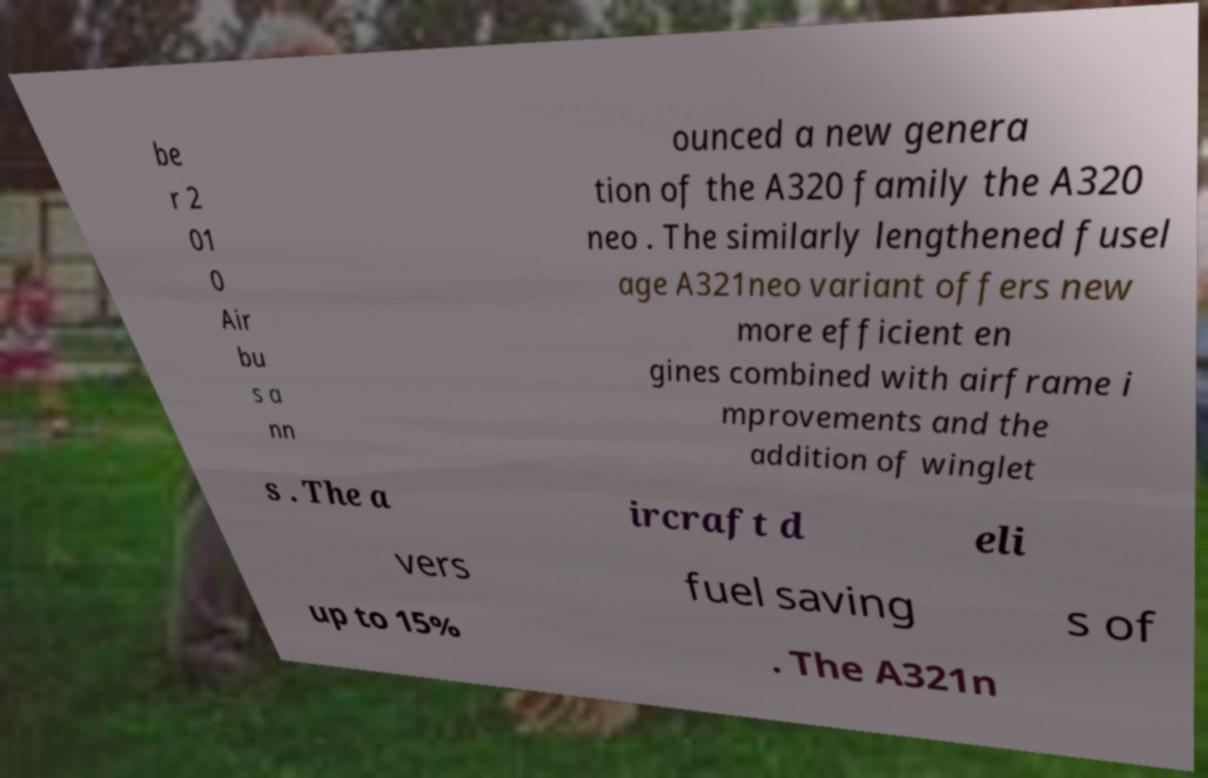There's text embedded in this image that I need extracted. Can you transcribe it verbatim? be r 2 01 0 Air bu s a nn ounced a new genera tion of the A320 family the A320 neo . The similarly lengthened fusel age A321neo variant offers new more efficient en gines combined with airframe i mprovements and the addition of winglet s . The a ircraft d eli vers fuel saving s of up to 15% . The A321n 